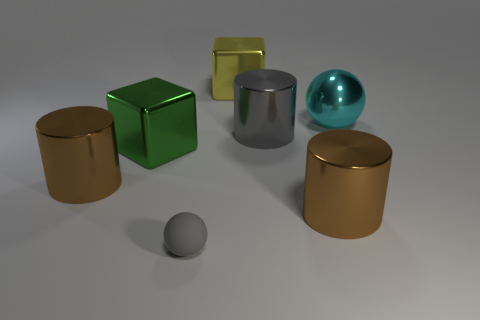There is a brown cylinder that is right of the cylinder that is left of the big green cube behind the small gray rubber sphere; how big is it?
Your answer should be very brief. Large. Are there any green things right of the metallic thing behind the cyan shiny ball?
Your answer should be very brief. No. What number of big metal cylinders are on the left side of the big brown metal object right of the cylinder on the left side of the gray metallic cylinder?
Provide a short and direct response. 2. What color is the large metal cylinder that is in front of the green shiny thing and to the right of the yellow object?
Provide a succinct answer. Brown. What number of large metallic objects have the same color as the tiny ball?
Ensure brevity in your answer.  1. What number of blocks are small things or brown shiny things?
Keep it short and to the point. 0. There is a shiny ball that is the same size as the yellow cube; what is its color?
Keep it short and to the point. Cyan. There is a small gray ball in front of the big brown metal object that is right of the yellow object; are there any spheres on the left side of it?
Offer a terse response. No. What size is the yellow cube?
Give a very brief answer. Large. What number of objects are big cyan shiny spheres or gray cylinders?
Ensure brevity in your answer.  2. 